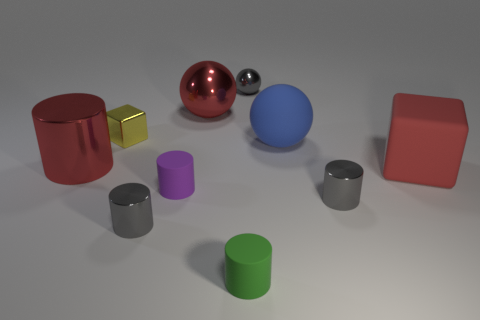Do the tiny purple rubber thing and the gray object that is behind the purple cylinder have the same shape?
Provide a short and direct response. No. Are there fewer small gray spheres that are behind the red rubber thing than rubber cylinders that are behind the green rubber cylinder?
Make the answer very short. No. There is a large red object that is the same shape as the yellow metallic thing; what material is it?
Give a very brief answer. Rubber. Is there any other thing that is made of the same material as the big blue thing?
Provide a succinct answer. Yes. Does the large rubber block have the same color as the tiny shiny cube?
Offer a terse response. No. The blue object that is the same material as the green thing is what shape?
Offer a very short reply. Sphere. What number of large metallic objects have the same shape as the small purple thing?
Make the answer very short. 1. What is the shape of the tiny gray thing that is behind the matte thing on the right side of the blue thing?
Your response must be concise. Sphere. Is the size of the matte cylinder that is on the right side of the purple cylinder the same as the purple cylinder?
Your response must be concise. Yes. How big is the red thing that is in front of the big blue thing and to the right of the red cylinder?
Offer a terse response. Large. 